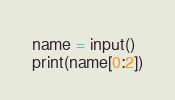<code> <loc_0><loc_0><loc_500><loc_500><_Python_>name = input()
print(name[0:2])</code> 